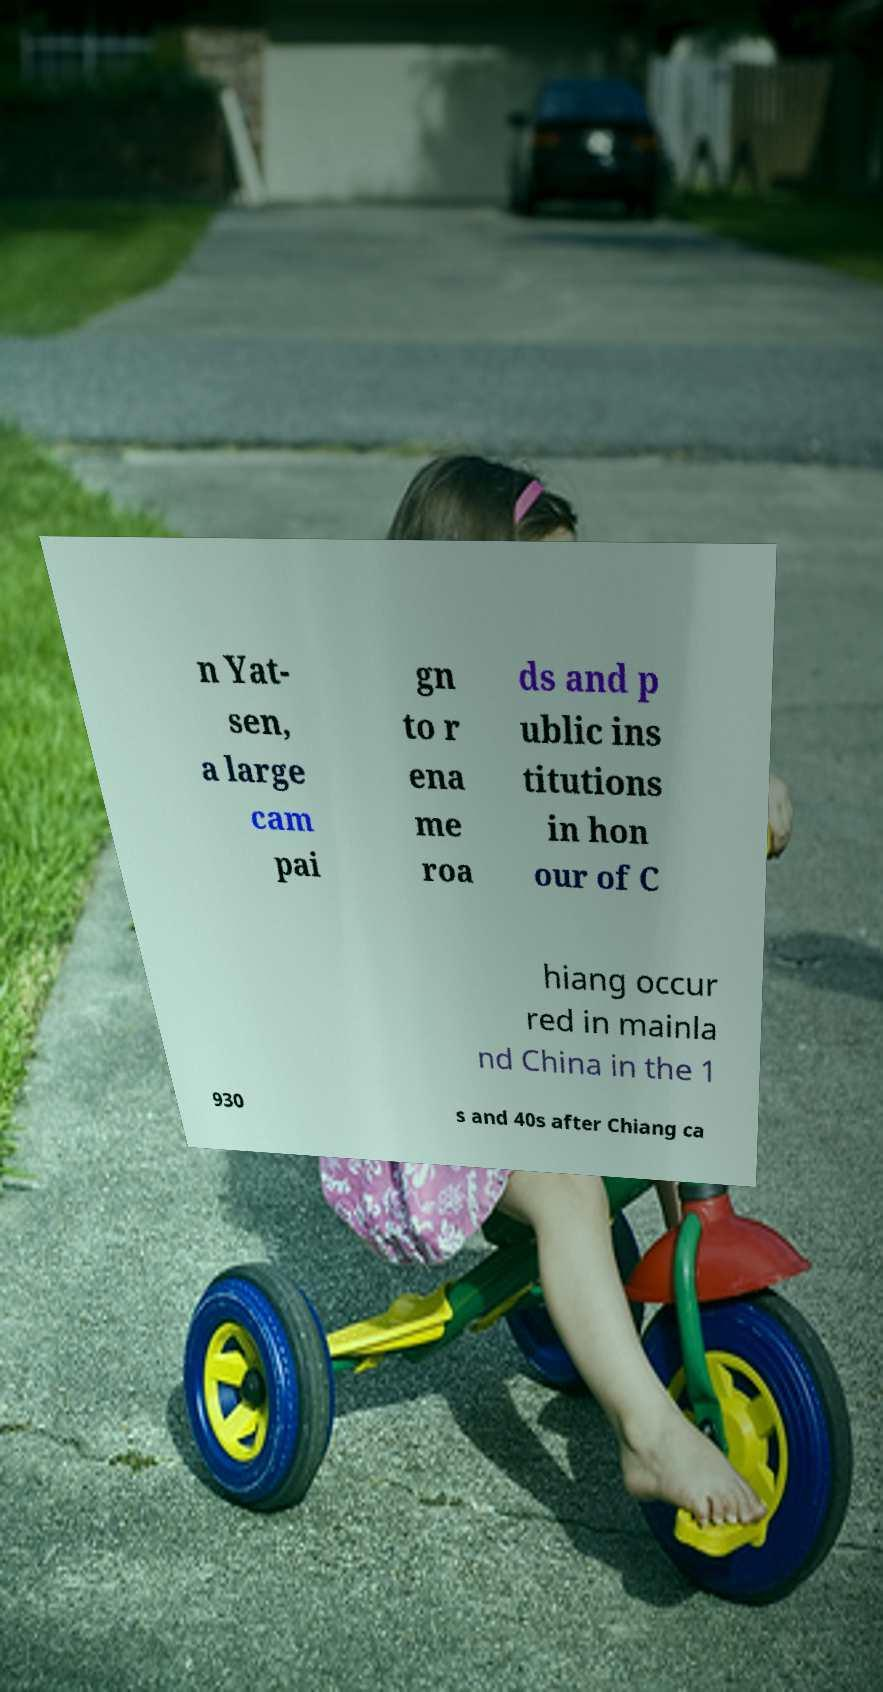There's text embedded in this image that I need extracted. Can you transcribe it verbatim? n Yat- sen, a large cam pai gn to r ena me roa ds and p ublic ins titutions in hon our of C hiang occur red in mainla nd China in the 1 930 s and 40s after Chiang ca 